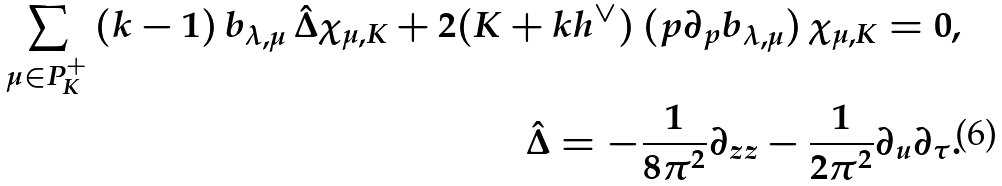<formula> <loc_0><loc_0><loc_500><loc_500>\sum _ { \mu \in P ^ { + } _ { K } } \, ( k - 1 ) \, b _ { \lambda , \mu } \, \hat { \Delta } \chi _ { \mu , K } + 2 ( K + k h ^ { \vee } ) \, ( p \partial _ { p } b _ { \lambda , \mu } ) \, \chi _ { \mu , K } = 0 , \\ \hat { \Delta } = - \frac { 1 } { 8 \pi ^ { 2 } } \partial _ { z z } - \frac { 1 } { 2 \pi ^ { 2 } } \partial _ { u } \partial _ { \tau } .</formula> 